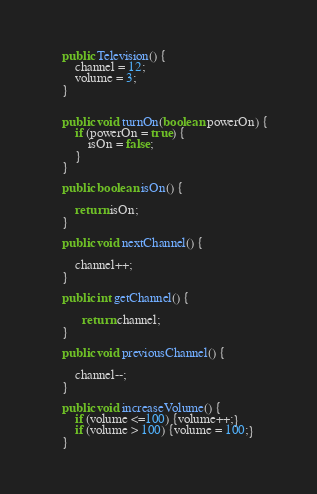<code> <loc_0><loc_0><loc_500><loc_500><_Java_>
    public Television() {
        channel = 12;
        volume = 3;
    }


    public void turnOn(boolean powerOn) {
        if (powerOn = true) {
            isOn = false;
        }
    }

    public boolean isOn() {

        return isOn;
    }

    public void nextChannel() {

        channel++;
    }

    public int getChannel() {

          return channel;
    }

    public void previousChannel() {

        channel--;
    }

    public void increaseVolume() {
        if (volume <=100) {volume++;}
        if (volume > 100) {volume = 100;}
    }
</code> 